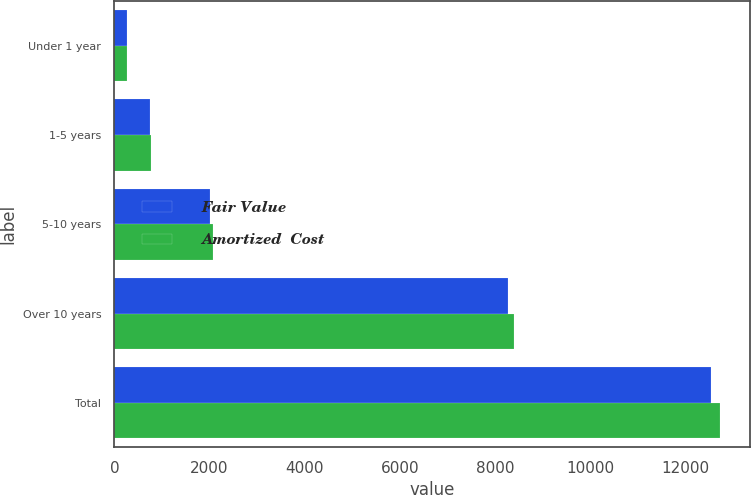Convert chart. <chart><loc_0><loc_0><loc_500><loc_500><stacked_bar_chart><ecel><fcel>Under 1 year<fcel>1-5 years<fcel>5-10 years<fcel>Over 10 years<fcel>Total<nl><fcel>Fair Value<fcel>263<fcel>750<fcel>2013<fcel>8276<fcel>12550<nl><fcel>Amortized  Cost<fcel>264<fcel>762<fcel>2080<fcel>8391<fcel>12728<nl></chart> 